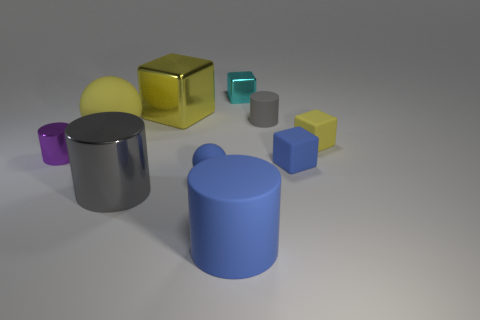Is the color of the small sphere the same as the big matte cylinder?
Provide a short and direct response. Yes. Is there a cylinder behind the gray cylinder in front of the small purple metallic thing?
Your answer should be very brief. Yes. There is a big shiny thing that is the same shape as the tiny purple thing; what color is it?
Offer a terse response. Gray. How many small rubber spheres have the same color as the large rubber cylinder?
Make the answer very short. 1. What color is the big metal thing that is in front of the blue object that is on the left side of the blue matte thing in front of the large metallic cylinder?
Make the answer very short. Gray. Is the big sphere made of the same material as the large blue object?
Make the answer very short. Yes. Does the big gray metallic object have the same shape as the tiny yellow rubber object?
Your response must be concise. No. Are there an equal number of gray shiny objects in front of the big matte cylinder and large metallic things that are right of the tiny metal cube?
Keep it short and to the point. Yes. There is a tiny cylinder that is the same material as the tiny yellow block; what is its color?
Make the answer very short. Gray. How many cylinders are made of the same material as the big block?
Give a very brief answer. 2. 